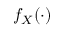Convert formula to latex. <formula><loc_0><loc_0><loc_500><loc_500>f _ { X } ( \cdot )</formula> 